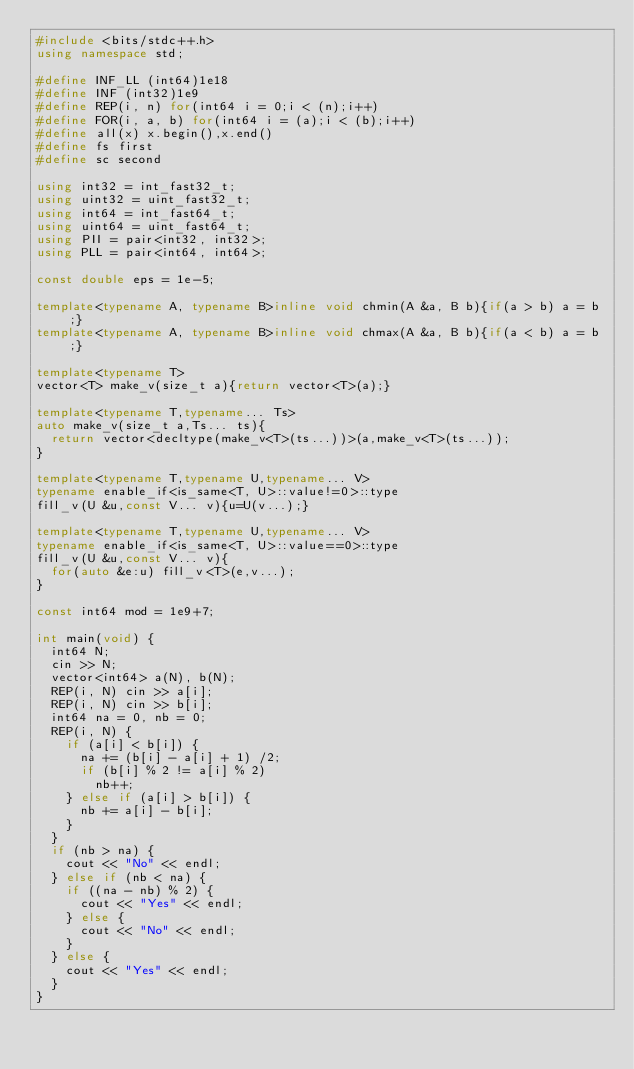Convert code to text. <code><loc_0><loc_0><loc_500><loc_500><_C++_>#include <bits/stdc++.h>
using namespace std;

#define INF_LL (int64)1e18
#define INF (int32)1e9
#define REP(i, n) for(int64 i = 0;i < (n);i++)
#define FOR(i, a, b) for(int64 i = (a);i < (b);i++)
#define all(x) x.begin(),x.end()
#define fs first
#define sc second

using int32 = int_fast32_t;
using uint32 = uint_fast32_t;
using int64 = int_fast64_t;
using uint64 = uint_fast64_t;
using PII = pair<int32, int32>;
using PLL = pair<int64, int64>;

const double eps = 1e-5;

template<typename A, typename B>inline void chmin(A &a, B b){if(a > b) a = b;}
template<typename A, typename B>inline void chmax(A &a, B b){if(a < b) a = b;}

template<typename T>
vector<T> make_v(size_t a){return vector<T>(a);}

template<typename T,typename... Ts>
auto make_v(size_t a,Ts... ts){
  return vector<decltype(make_v<T>(ts...))>(a,make_v<T>(ts...));
}

template<typename T,typename U,typename... V>
typename enable_if<is_same<T, U>::value!=0>::type
fill_v(U &u,const V... v){u=U(v...);}

template<typename T,typename U,typename... V>
typename enable_if<is_same<T, U>::value==0>::type
fill_v(U &u,const V... v){
  for(auto &e:u) fill_v<T>(e,v...);
}

const int64 mod = 1e9+7;

int main(void) {
	int64 N;
	cin >> N;
	vector<int64> a(N), b(N);
	REP(i, N) cin >> a[i];
	REP(i, N) cin >> b[i];
	int64 na = 0, nb = 0;
	REP(i, N) {
		if (a[i] < b[i]) {
			na += (b[i] - a[i] + 1) /2;
			if (b[i] % 2 != a[i] % 2)
				nb++;
		} else if (a[i] > b[i]) {
			nb += a[i] - b[i];
		}
	}
	if (nb > na) {
		cout << "No" << endl;
	} else if (nb < na) {
		if ((na - nb) % 2) {
			cout << "Yes" << endl;
		} else {
			cout << "No" << endl;
		}
	} else {
		cout << "Yes" << endl;
	}
}
</code> 